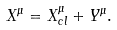<formula> <loc_0><loc_0><loc_500><loc_500>X ^ { \mu } = X ^ { \mu } _ { c l } + Y ^ { \mu } .</formula> 